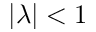Convert formula to latex. <formula><loc_0><loc_0><loc_500><loc_500>| \lambda | < 1</formula> 